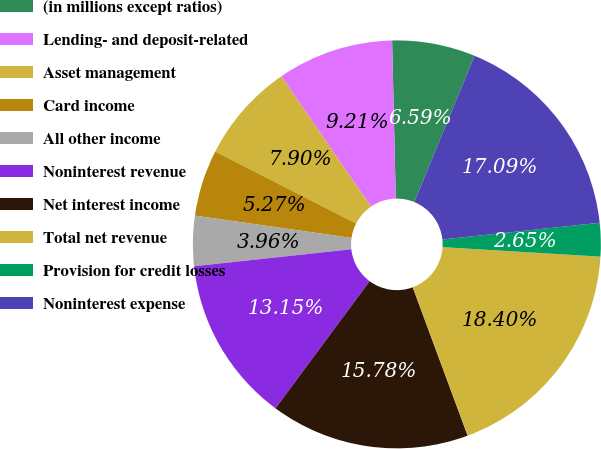Convert chart to OTSL. <chart><loc_0><loc_0><loc_500><loc_500><pie_chart><fcel>(in millions except ratios)<fcel>Lending- and deposit-related<fcel>Asset management<fcel>Card income<fcel>All other income<fcel>Noninterest revenue<fcel>Net interest income<fcel>Total net revenue<fcel>Provision for credit losses<fcel>Noninterest expense<nl><fcel>6.59%<fcel>9.21%<fcel>7.9%<fcel>5.27%<fcel>3.96%<fcel>13.15%<fcel>15.78%<fcel>18.4%<fcel>2.65%<fcel>17.09%<nl></chart> 